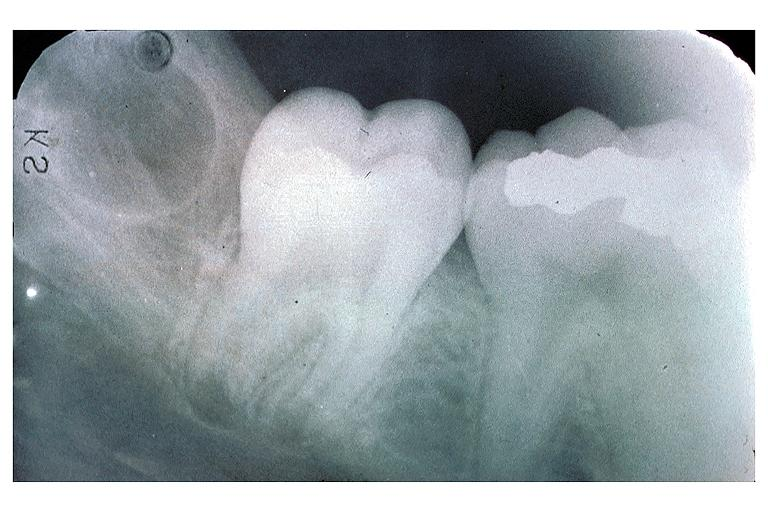what is present?
Answer the question using a single word or phrase. Oral 